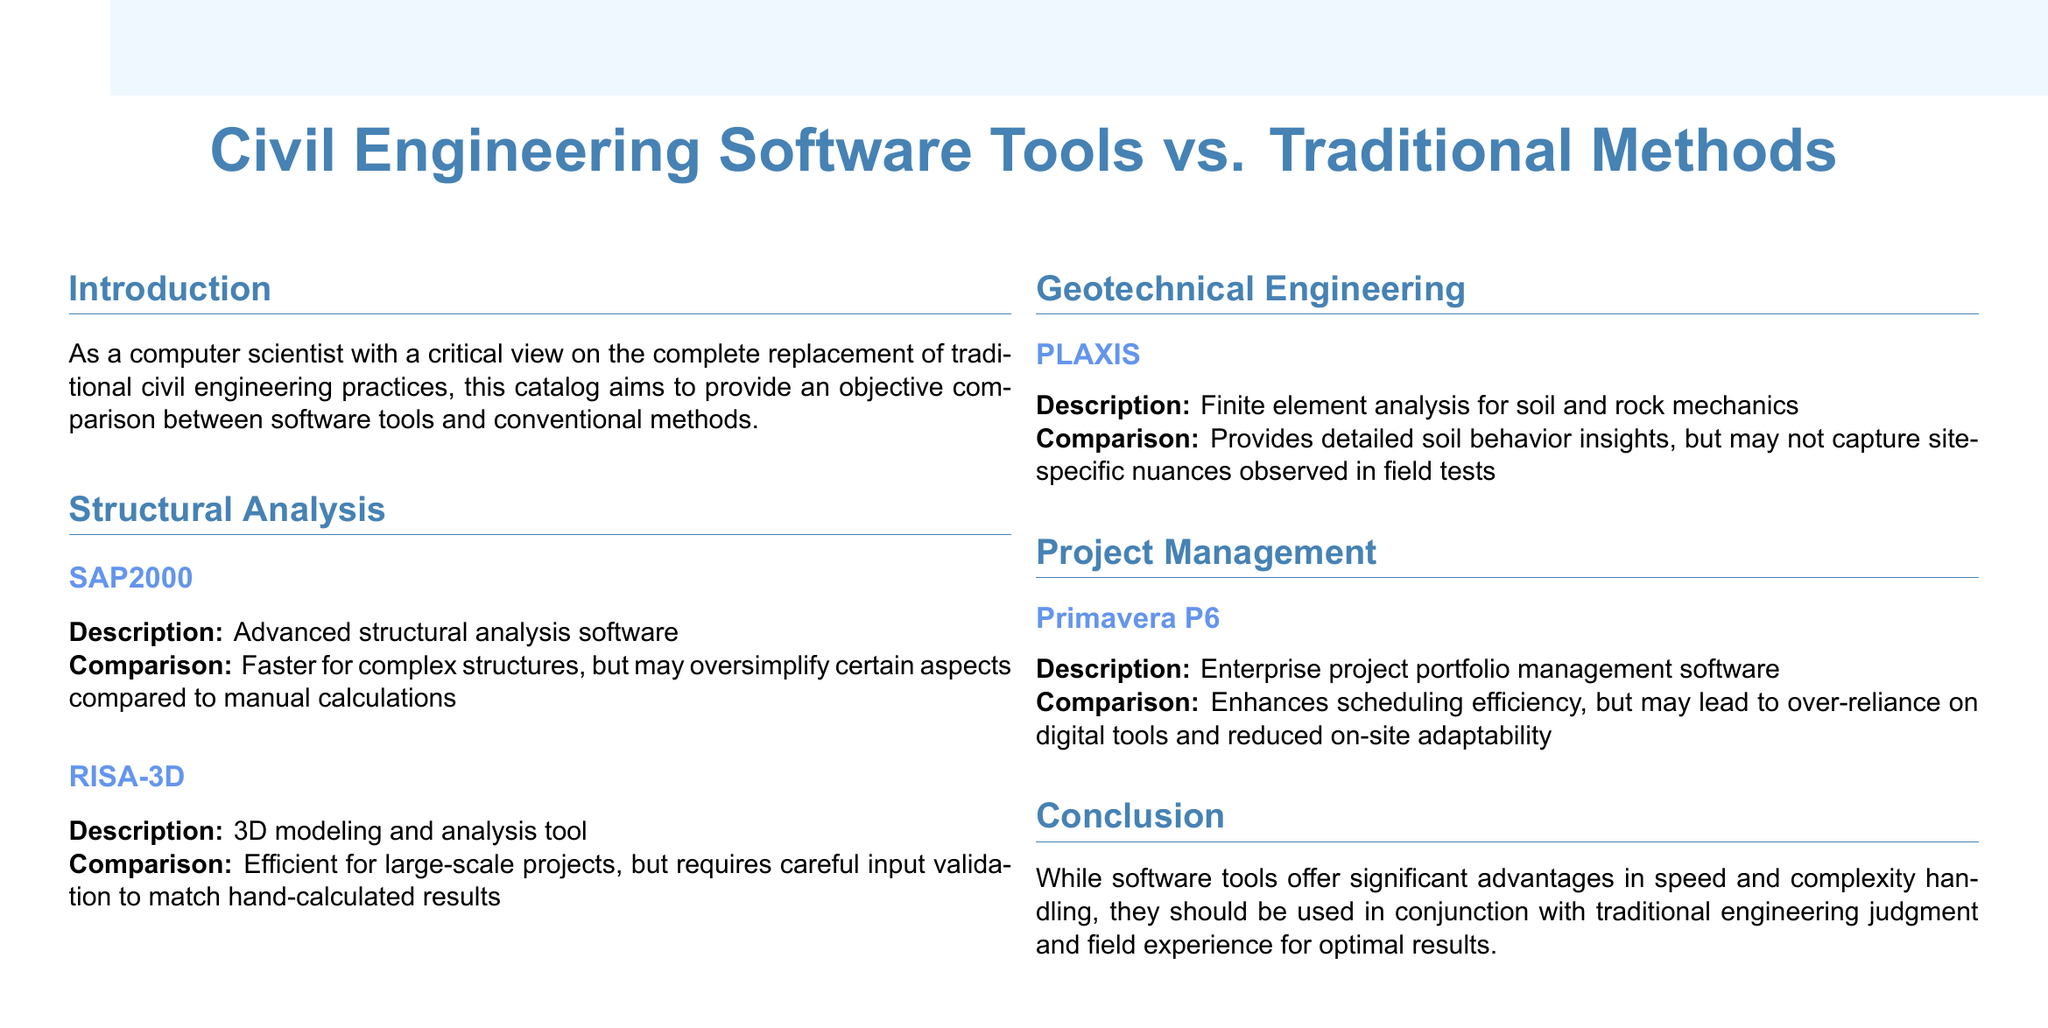What is the title of the catalog? The title is explicitly stated at the beginning of the document.
Answer: Civil Engineering Software Tools vs. Traditional Methods What is the first software tool mentioned in structural analysis? The first tool listed under structural analysis in the document.
Answer: SAP2000 Which software is used for geotechnical engineering? The document specifies the software tool used for geotechnical engineering.
Answer: PLAXIS What advantage does Primavera P6 offer? The document highlights a specific benefit of using Primavera P6 in project management.
Answer: Scheduling efficiency What is a downside of using SAP2000? The document outlines a limitation of SAP2000 in its comparison.
Answer: Oversimplify certain aspects How does RISA-3D help in projects? The document describes a key characteristic of RISA-3D related to project scale.
Answer: Efficient for large-scale projects What should software tools be combined with for optimal results? The conclusion of the document indicates what should accompany software tools.
Answer: Traditional engineering judgment What is a potential risk of over-reliance on software tools? The document mentions a consequence of depending too much on digital tools.
Answer: Reduced on-site adaptability 